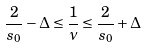<formula> <loc_0><loc_0><loc_500><loc_500>\frac { 2 } { s _ { 0 } } - \Delta \leq \frac { 1 } { \nu } \leq \frac { 2 } { s _ { 0 } } + \Delta</formula> 